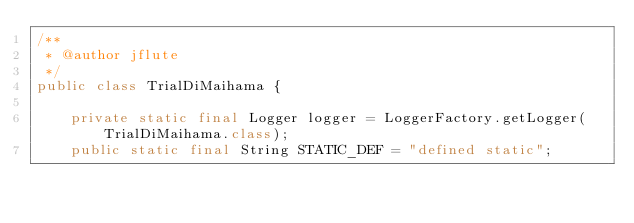<code> <loc_0><loc_0><loc_500><loc_500><_Java_>/**
 * @author jflute
 */
public class TrialDiMaihama {

    private static final Logger logger = LoggerFactory.getLogger(TrialDiMaihama.class);
    public static final String STATIC_DEF = "defined static";
</code> 